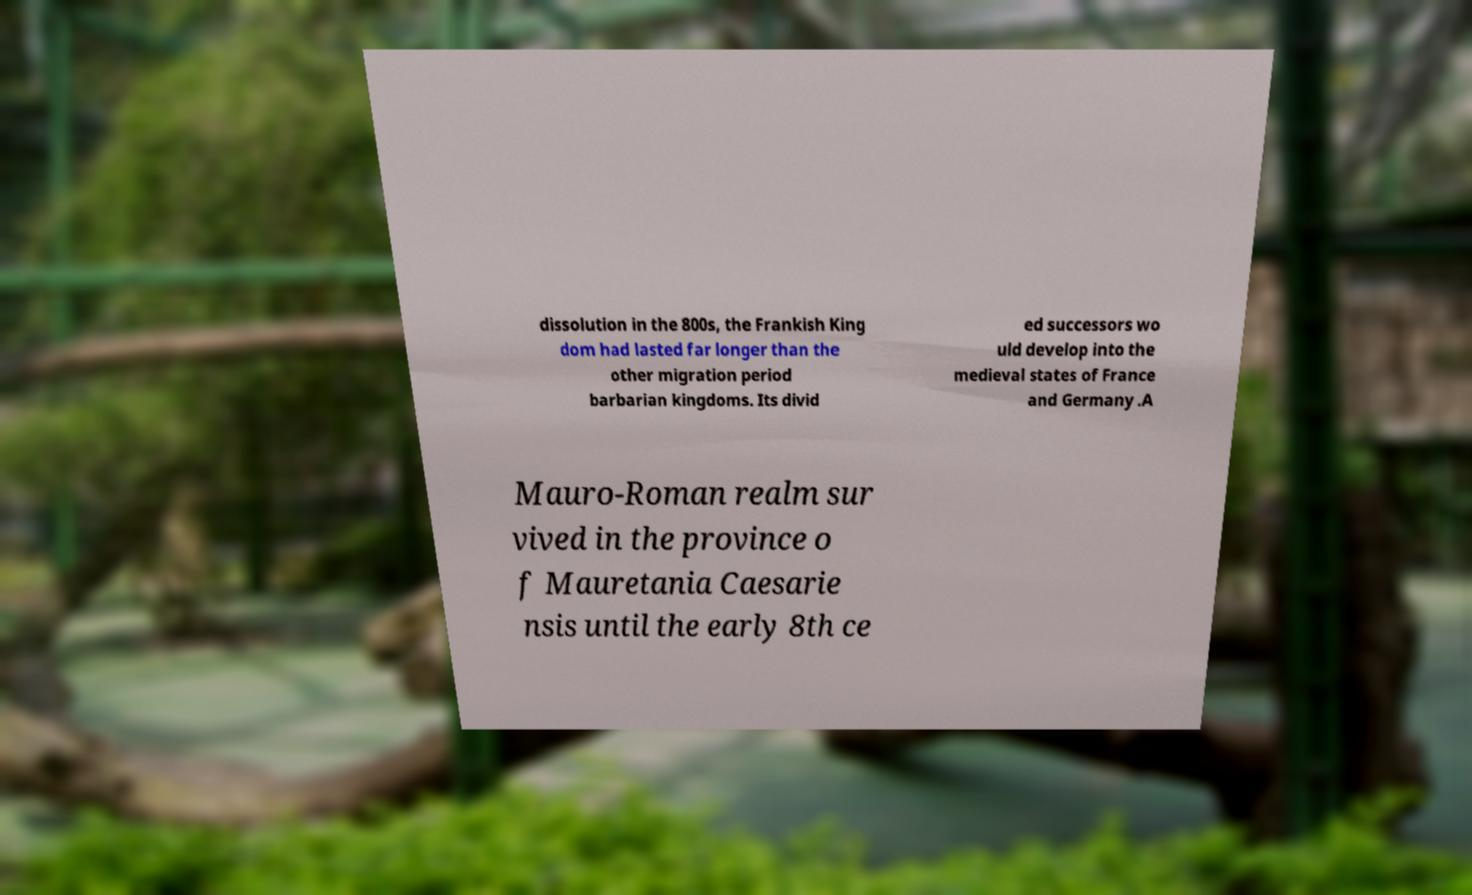Can you read and provide the text displayed in the image?This photo seems to have some interesting text. Can you extract and type it out for me? dissolution in the 800s, the Frankish King dom had lasted far longer than the other migration period barbarian kingdoms. Its divid ed successors wo uld develop into the medieval states of France and Germany .A Mauro-Roman realm sur vived in the province o f Mauretania Caesarie nsis until the early 8th ce 